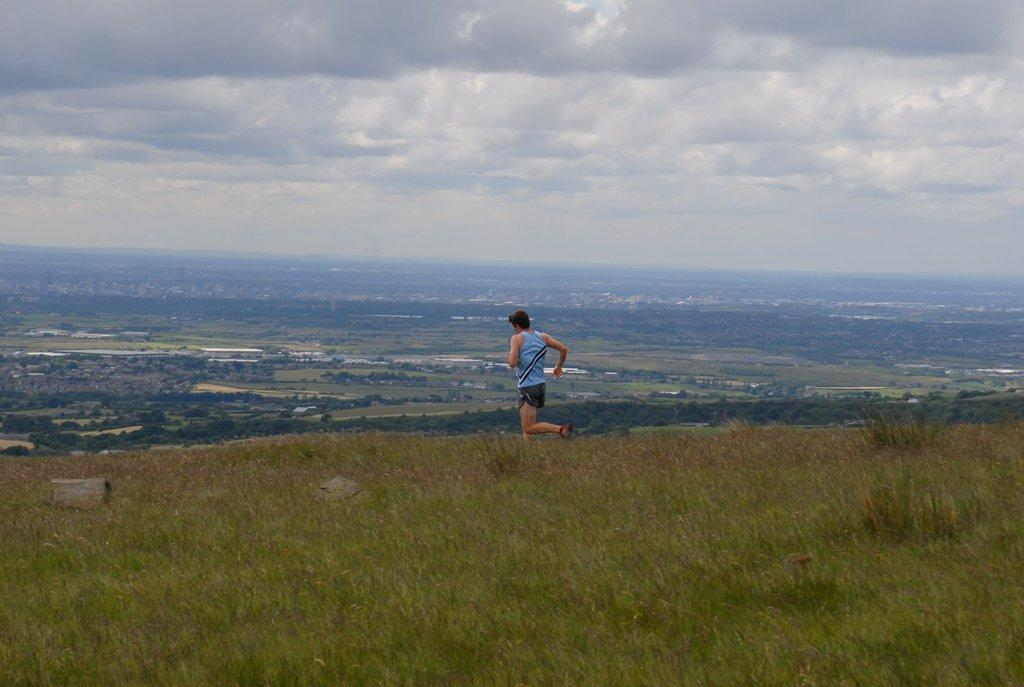Who is the person in the image? There is a man in the image. What is the man doing in the image? The man is running on the ground. What type of terrain is the man running on? There is grass in the image, so the man is running on grass. What can be seen in the background of the image? There are trees and the sky visible in the background of the image. What is the condition of the sky in the image? Clouds are present in the sky, so the sky appears partly cloudy. What type of vacation is the man taking in the image? There is no indication of a vacation in the image; it simply shows a man running on grass. What is the process for making the clouds in the image? The image is a photograph, not a drawing or painting, so there is no process for making the clouds; they are naturally occurring in the sky. 